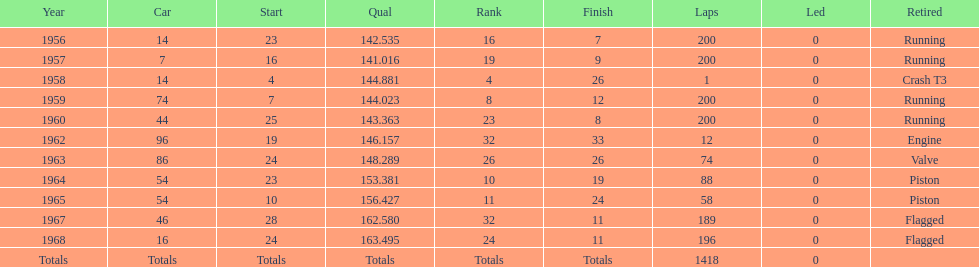On how many occasions did he finish all 200 circuits? 4. 